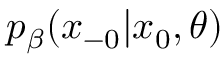Convert formula to latex. <formula><loc_0><loc_0><loc_500><loc_500>p _ { \beta } ( x _ { - 0 } | x _ { 0 } , \theta )</formula> 